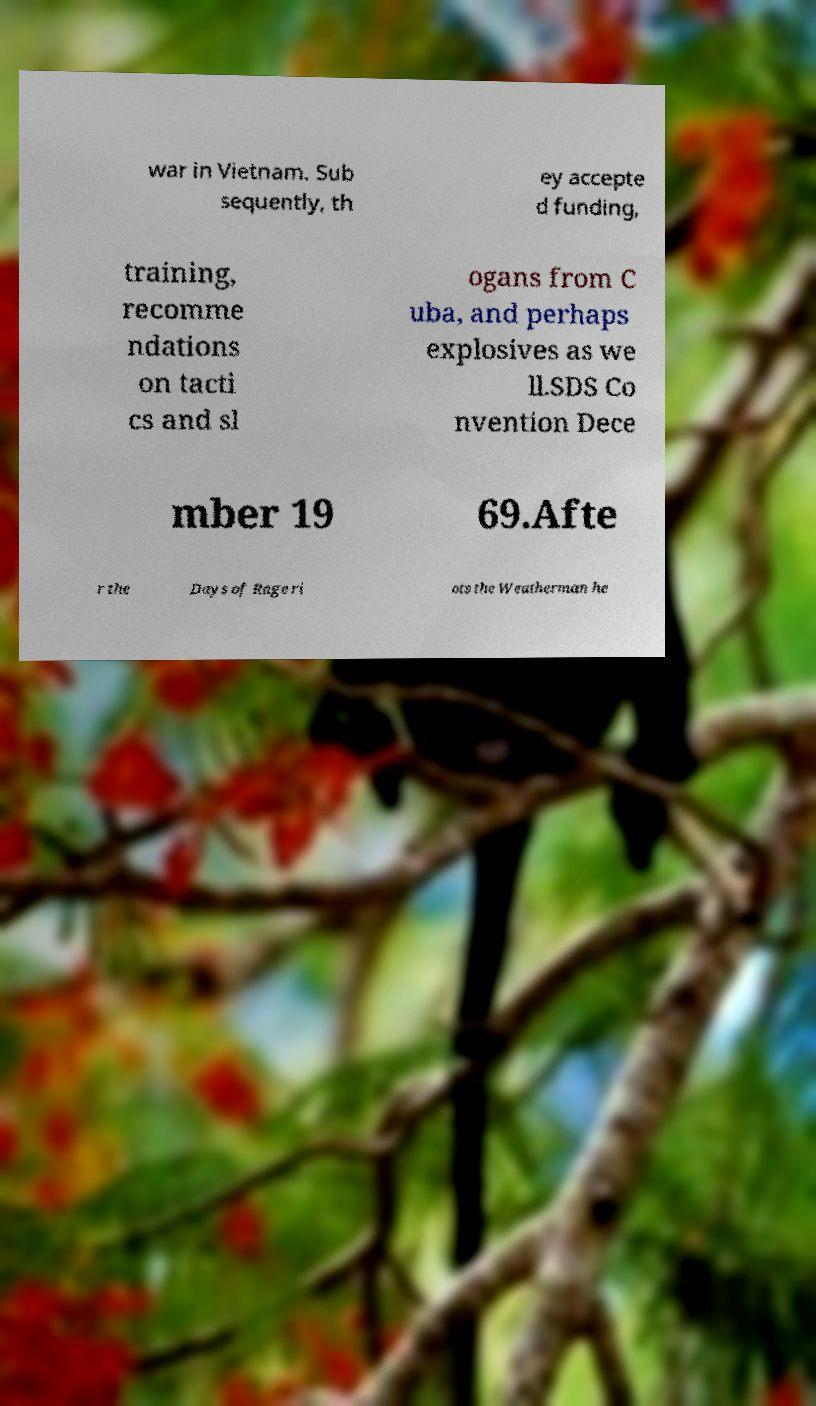Could you assist in decoding the text presented in this image and type it out clearly? war in Vietnam. Sub sequently, th ey accepte d funding, training, recomme ndations on tacti cs and sl ogans from C uba, and perhaps explosives as we ll.SDS Co nvention Dece mber 19 69.Afte r the Days of Rage ri ots the Weatherman he 